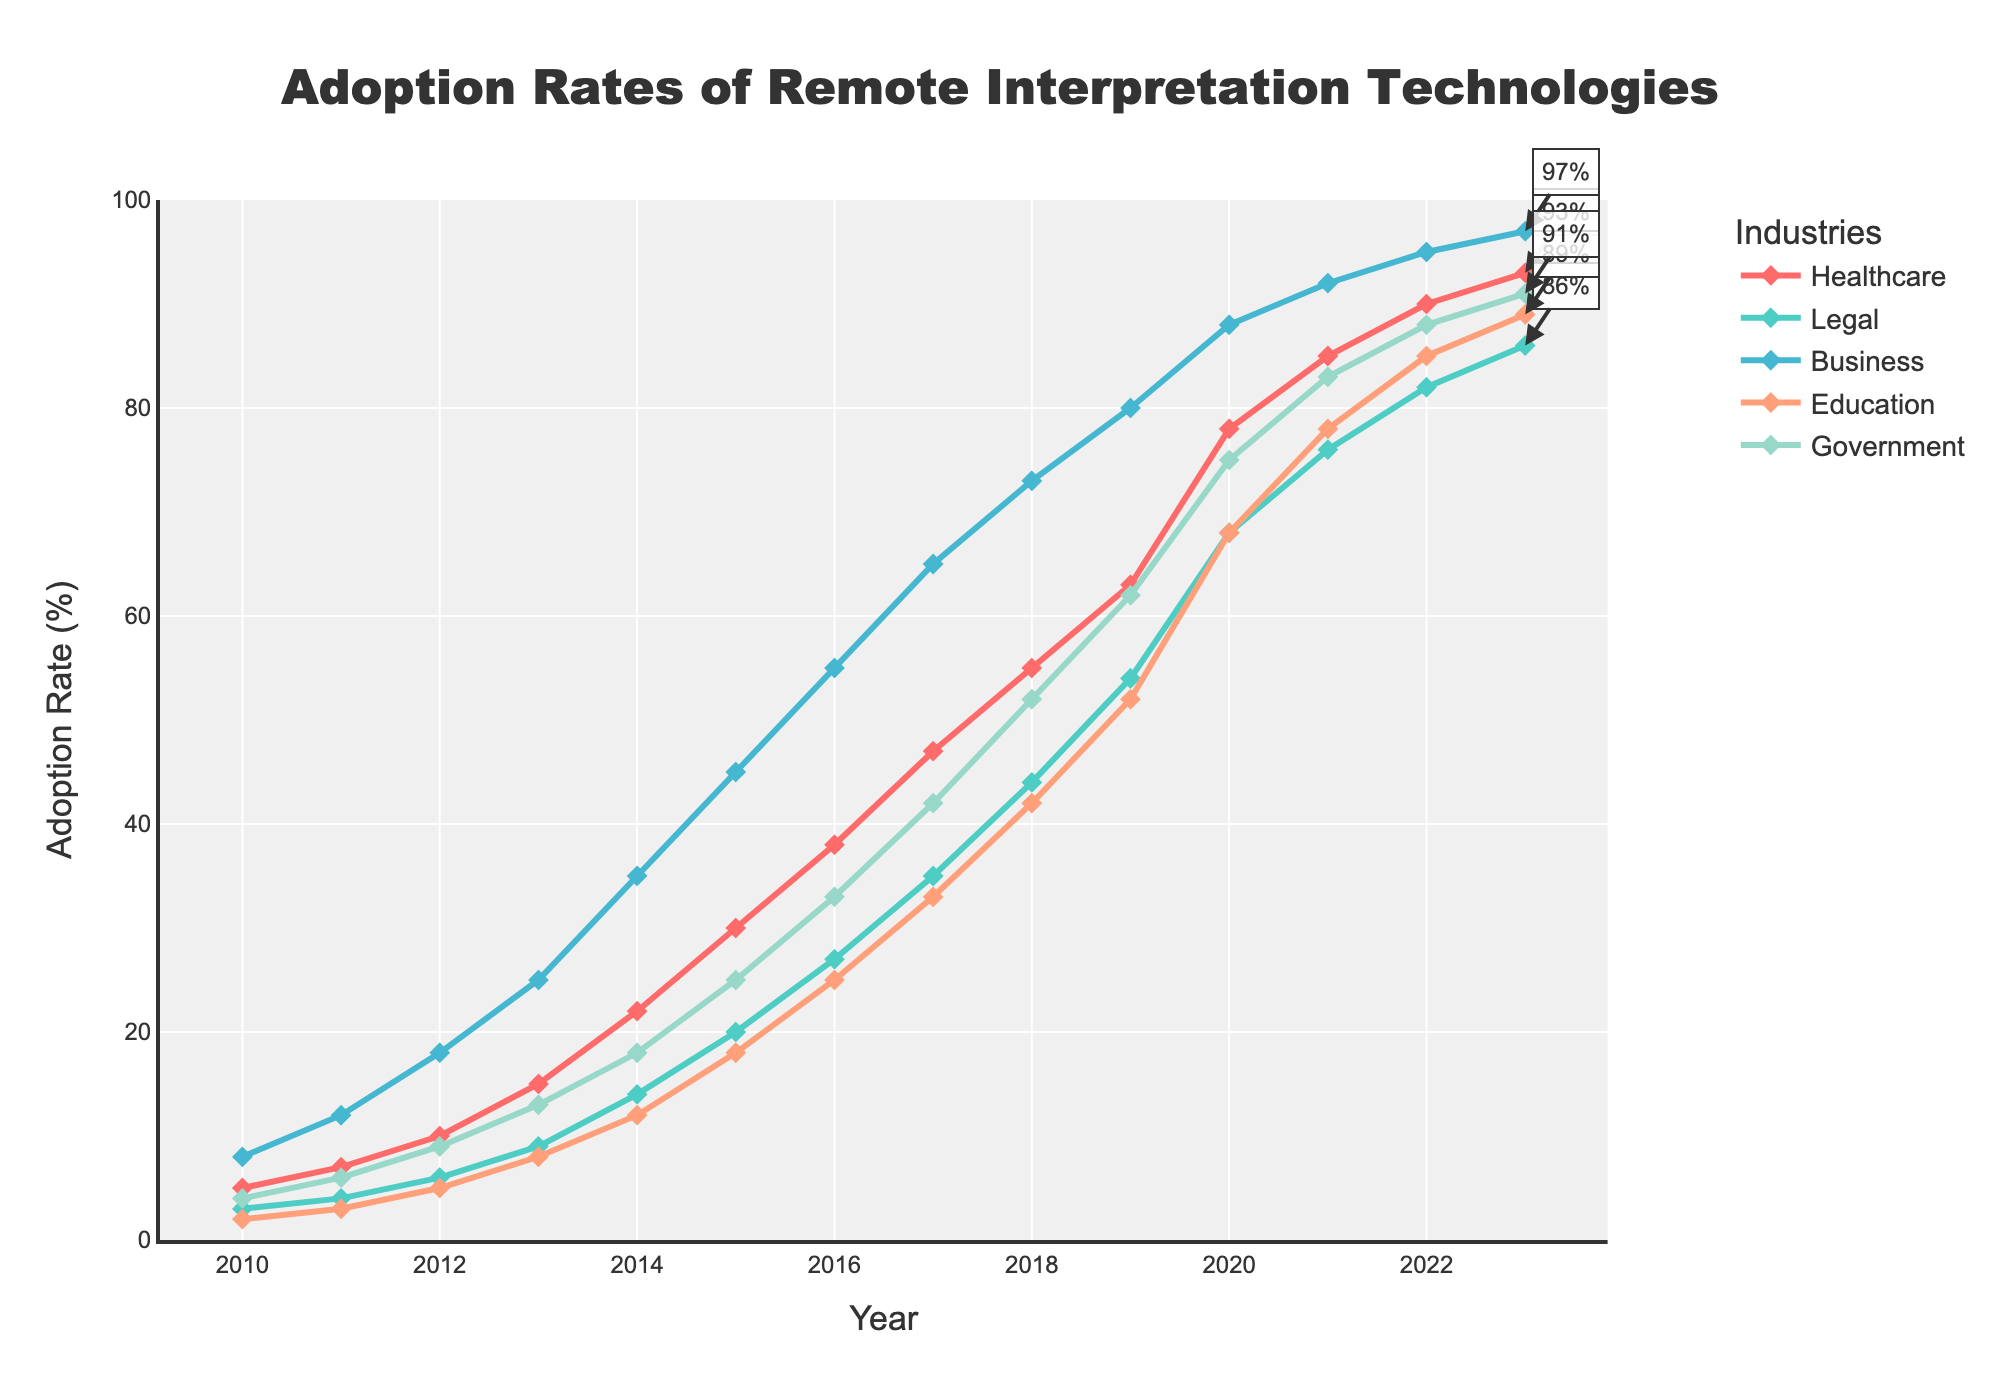What's the trend of adoption rates of remote interpretation technologies in the Healthcare industry from 2010 to 2023? The adoption rates in the Healthcare industry have been increasing steadily over the years. In 2010, the rate was 5%, and it gradually increased each year, reaching 93% in 2023.
Answer: Steady increase How does the adoption rate of remote interpretation technologies in Education in 2020 compare to that in 2015? The adoption rate in Education in 2020 is 68%, compared to 18% in 2015. Subtract the 2015 rate from the 2020 rate (68% - 18%) to find the difference.
Answer: 50% higher Which industry had the highest adoption rate in 2013, and what was that rate? In 2013, the Business industry had the highest adoption rate at 25%. Compare the rates across all industries for the year 2013.
Answer: Business, 25% By how much did the Government's adoption rate increase from 2010 to 2023? The Government's adoption rate in 2010 was 4%, and in 2023 it is 91%. Calculate the difference by subtracting the 2010 rate from the 2023 rate (91% - 4%).
Answer: 87% What is the average adoption rate of remote interpretation technologies across all industries in 2021? Sum the adoption rates for Healthcare, Legal, Business, Education, and Government in 2021, which are 85%, 76%, 92%, 78%, and 83%, respectively. Then divide by the number of industries (5) to find the average. (85 + 76 + 92 + 78 + 83) / 5 = 82.8%.
Answer: 82.8% Is the adoption rate of remote interpretation technologies in the Legal industry higher or lower than that in the Government industry in 2022? In 2022, the adoption rate in the Legal industry is 82%, and in the Government industry, it is 88%. Compare the two values.
Answer: Lower What is the median adoption rate for the Business industry from 2010 to 2023? Organize the following rates in ascending order: [8, 12, 18, 25, 35, 45, 55, 65, 73, 80, 88, 92, 95, 97]. Since there are 14 rates, the median is the average of the 7th and 8th values, (55 + 65)/2.
Answer: 60% Was there any year when all industries had an adoption rate below 50%? Review the adoption rates for all industries each year and identify the year(s) when all rates were below 50%. Notice that no year meets this criterion as rates exceed 50% for some industries starting from 2015.
Answer: No 